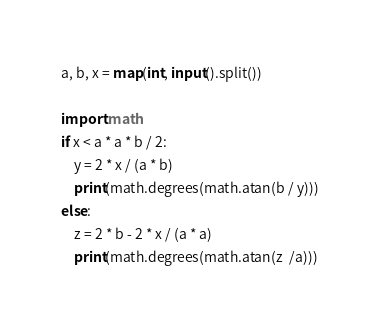Convert code to text. <code><loc_0><loc_0><loc_500><loc_500><_Python_>a, b, x = map(int, input().split())

import math
if x < a * a * b / 2:
    y = 2 * x / (a * b)
    print(math.degrees(math.atan(b / y)))
else:
    z = 2 * b - 2 * x / (a * a)
    print(math.degrees(math.atan(z  /a)))
</code> 